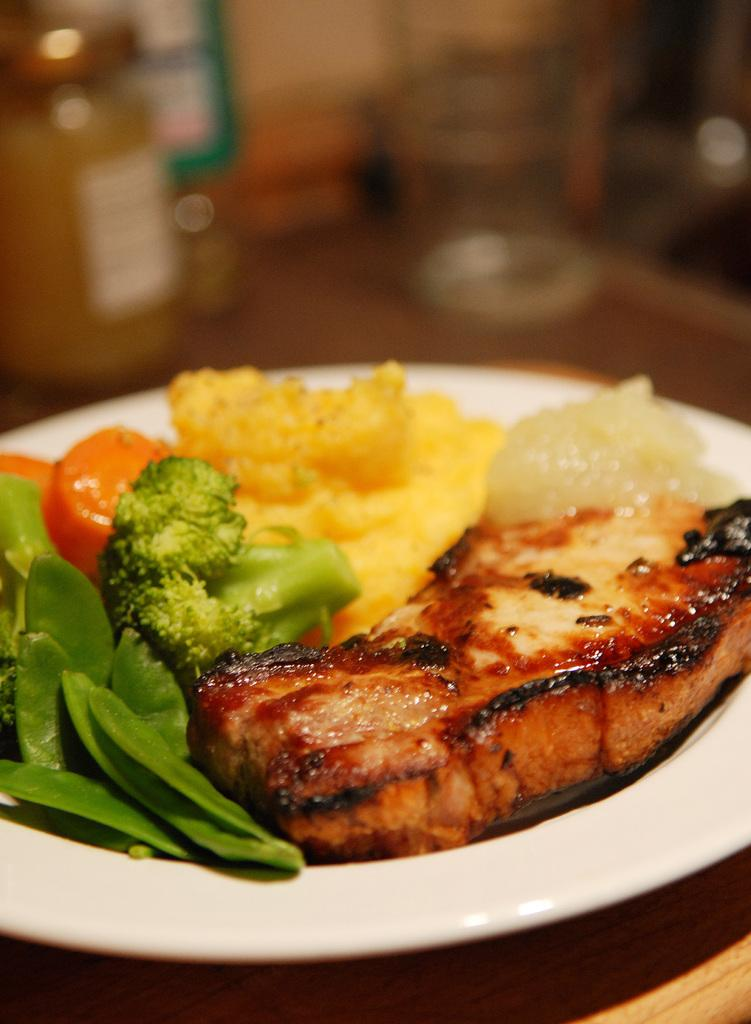What is on the plate that is visible in the image? There are food items on a plate in the image. What color is the plate? The plate is white in color. Where is the plate located? The plate is on a wooden table. Can you describe the background of the image? The background of the image is blurred. What type of string is being used to tie the event together in the image? There is no event or string present in the image; it only features a plate with food items on a wooden table. Can you see a tramp performing in the background of the image? There is no tramp or performance visible in the image; the background is blurred. 